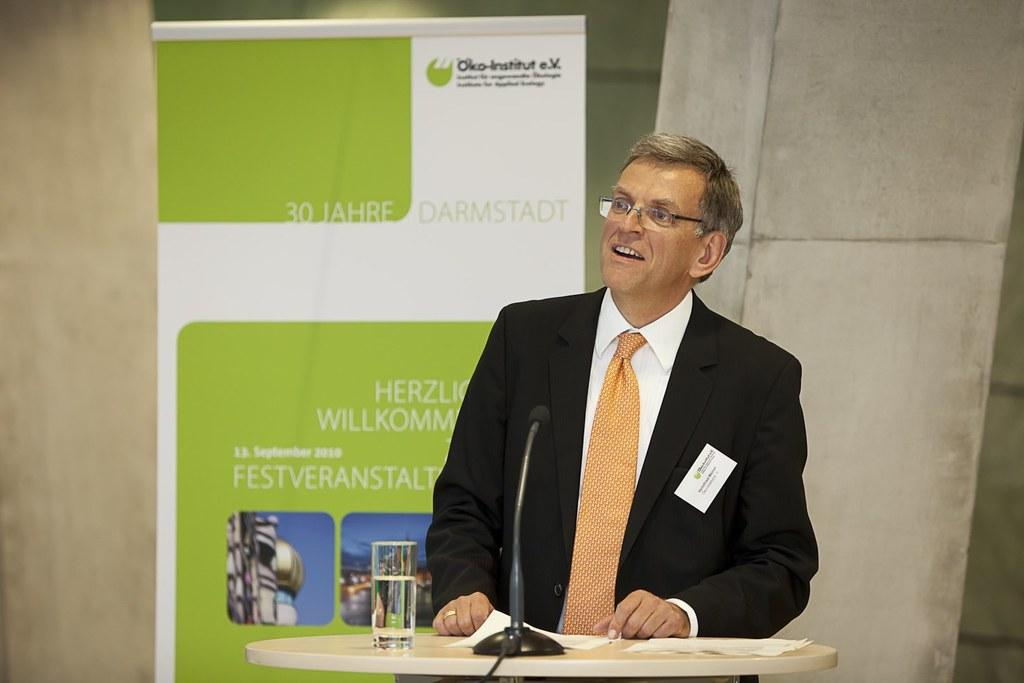What is located at the bottom of the image? There is a table at the bottom of the image. What object can be seen on the table? A microphone is present on the table. What else is on the table besides the microphone? There is a glass and papers on the table. Who is standing behind the table? A man is standing behind the table. What is behind the man? There is a banner behind the man, and a wall behind the banner. How many zebras are visible in the image? There are no zebras present in the image. What type of cloth is draped over the man's shoulders in the image? There is no cloth draped over the man's shoulders in the image. 